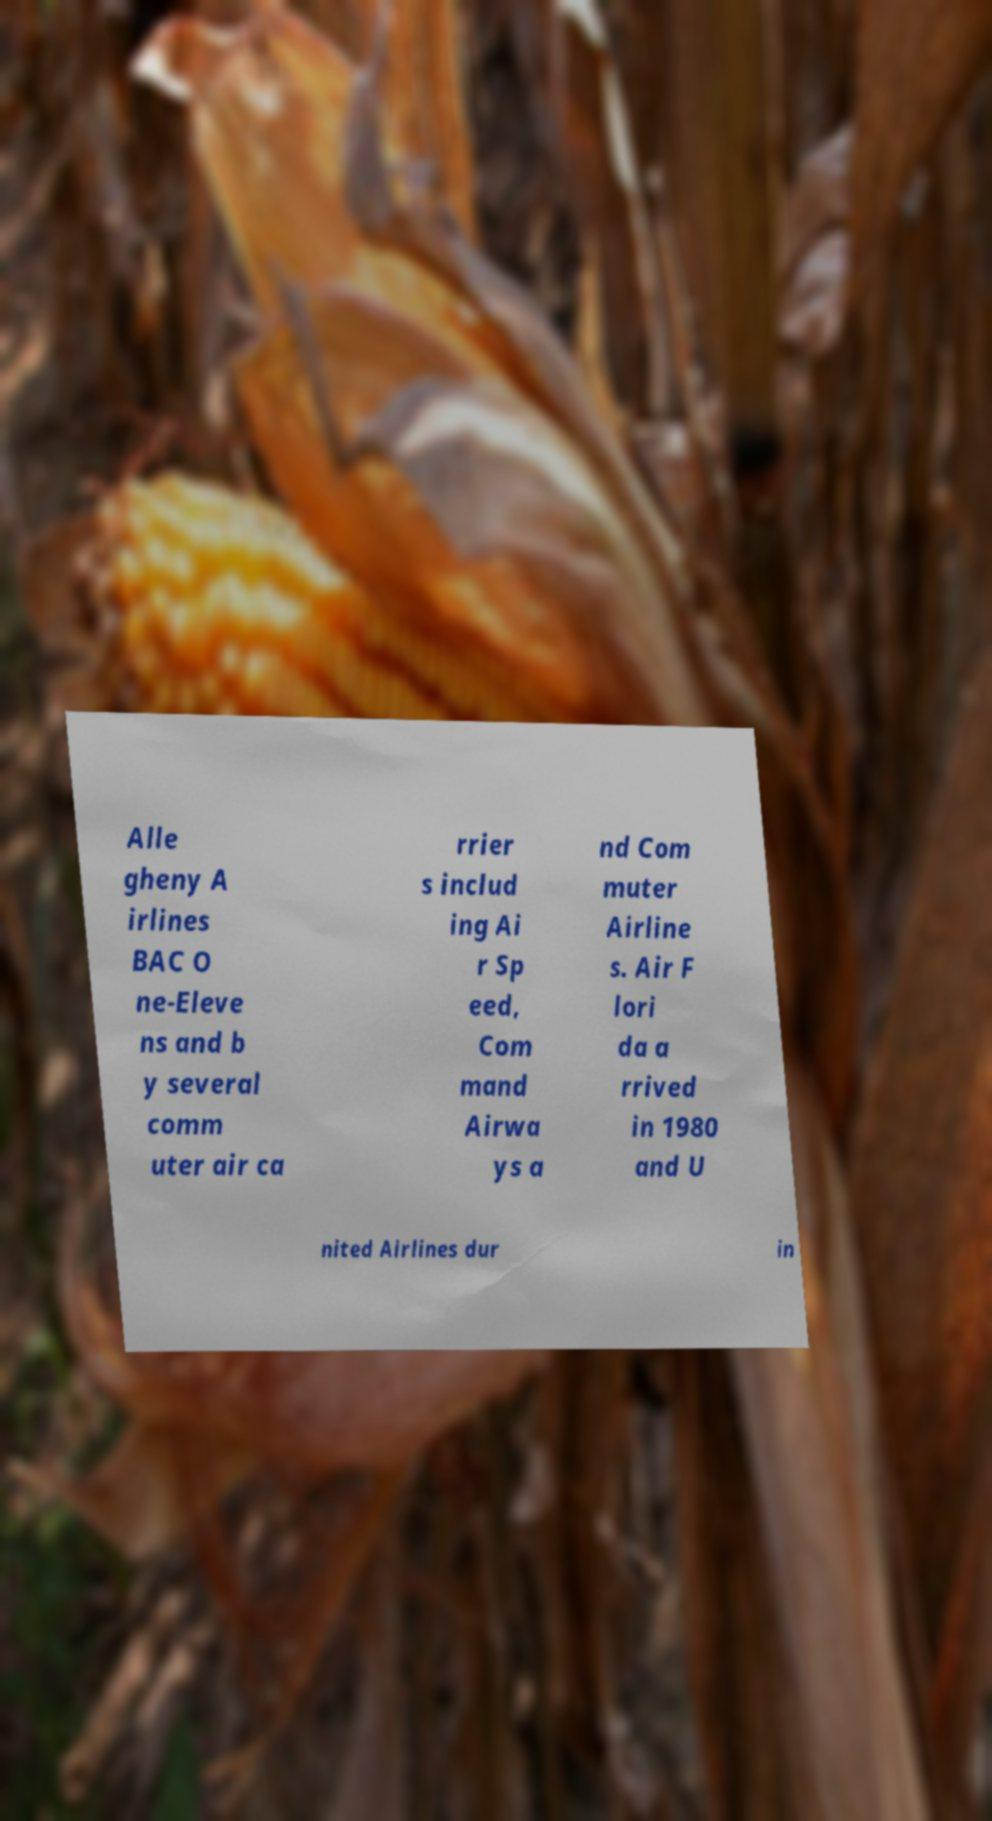Please identify and transcribe the text found in this image. Alle gheny A irlines BAC O ne-Eleve ns and b y several comm uter air ca rrier s includ ing Ai r Sp eed, Com mand Airwa ys a nd Com muter Airline s. Air F lori da a rrived in 1980 and U nited Airlines dur in 